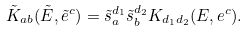Convert formula to latex. <formula><loc_0><loc_0><loc_500><loc_500>\tilde { K } _ { a b } ( \tilde { E } , \tilde { e } ^ { c } ) = \tilde { s } _ { a } ^ { d _ { 1 } } \tilde { s } _ { b } ^ { d _ { 2 } } K _ { d _ { 1 } d _ { 2 } } ( E , e ^ { c } ) .</formula> 